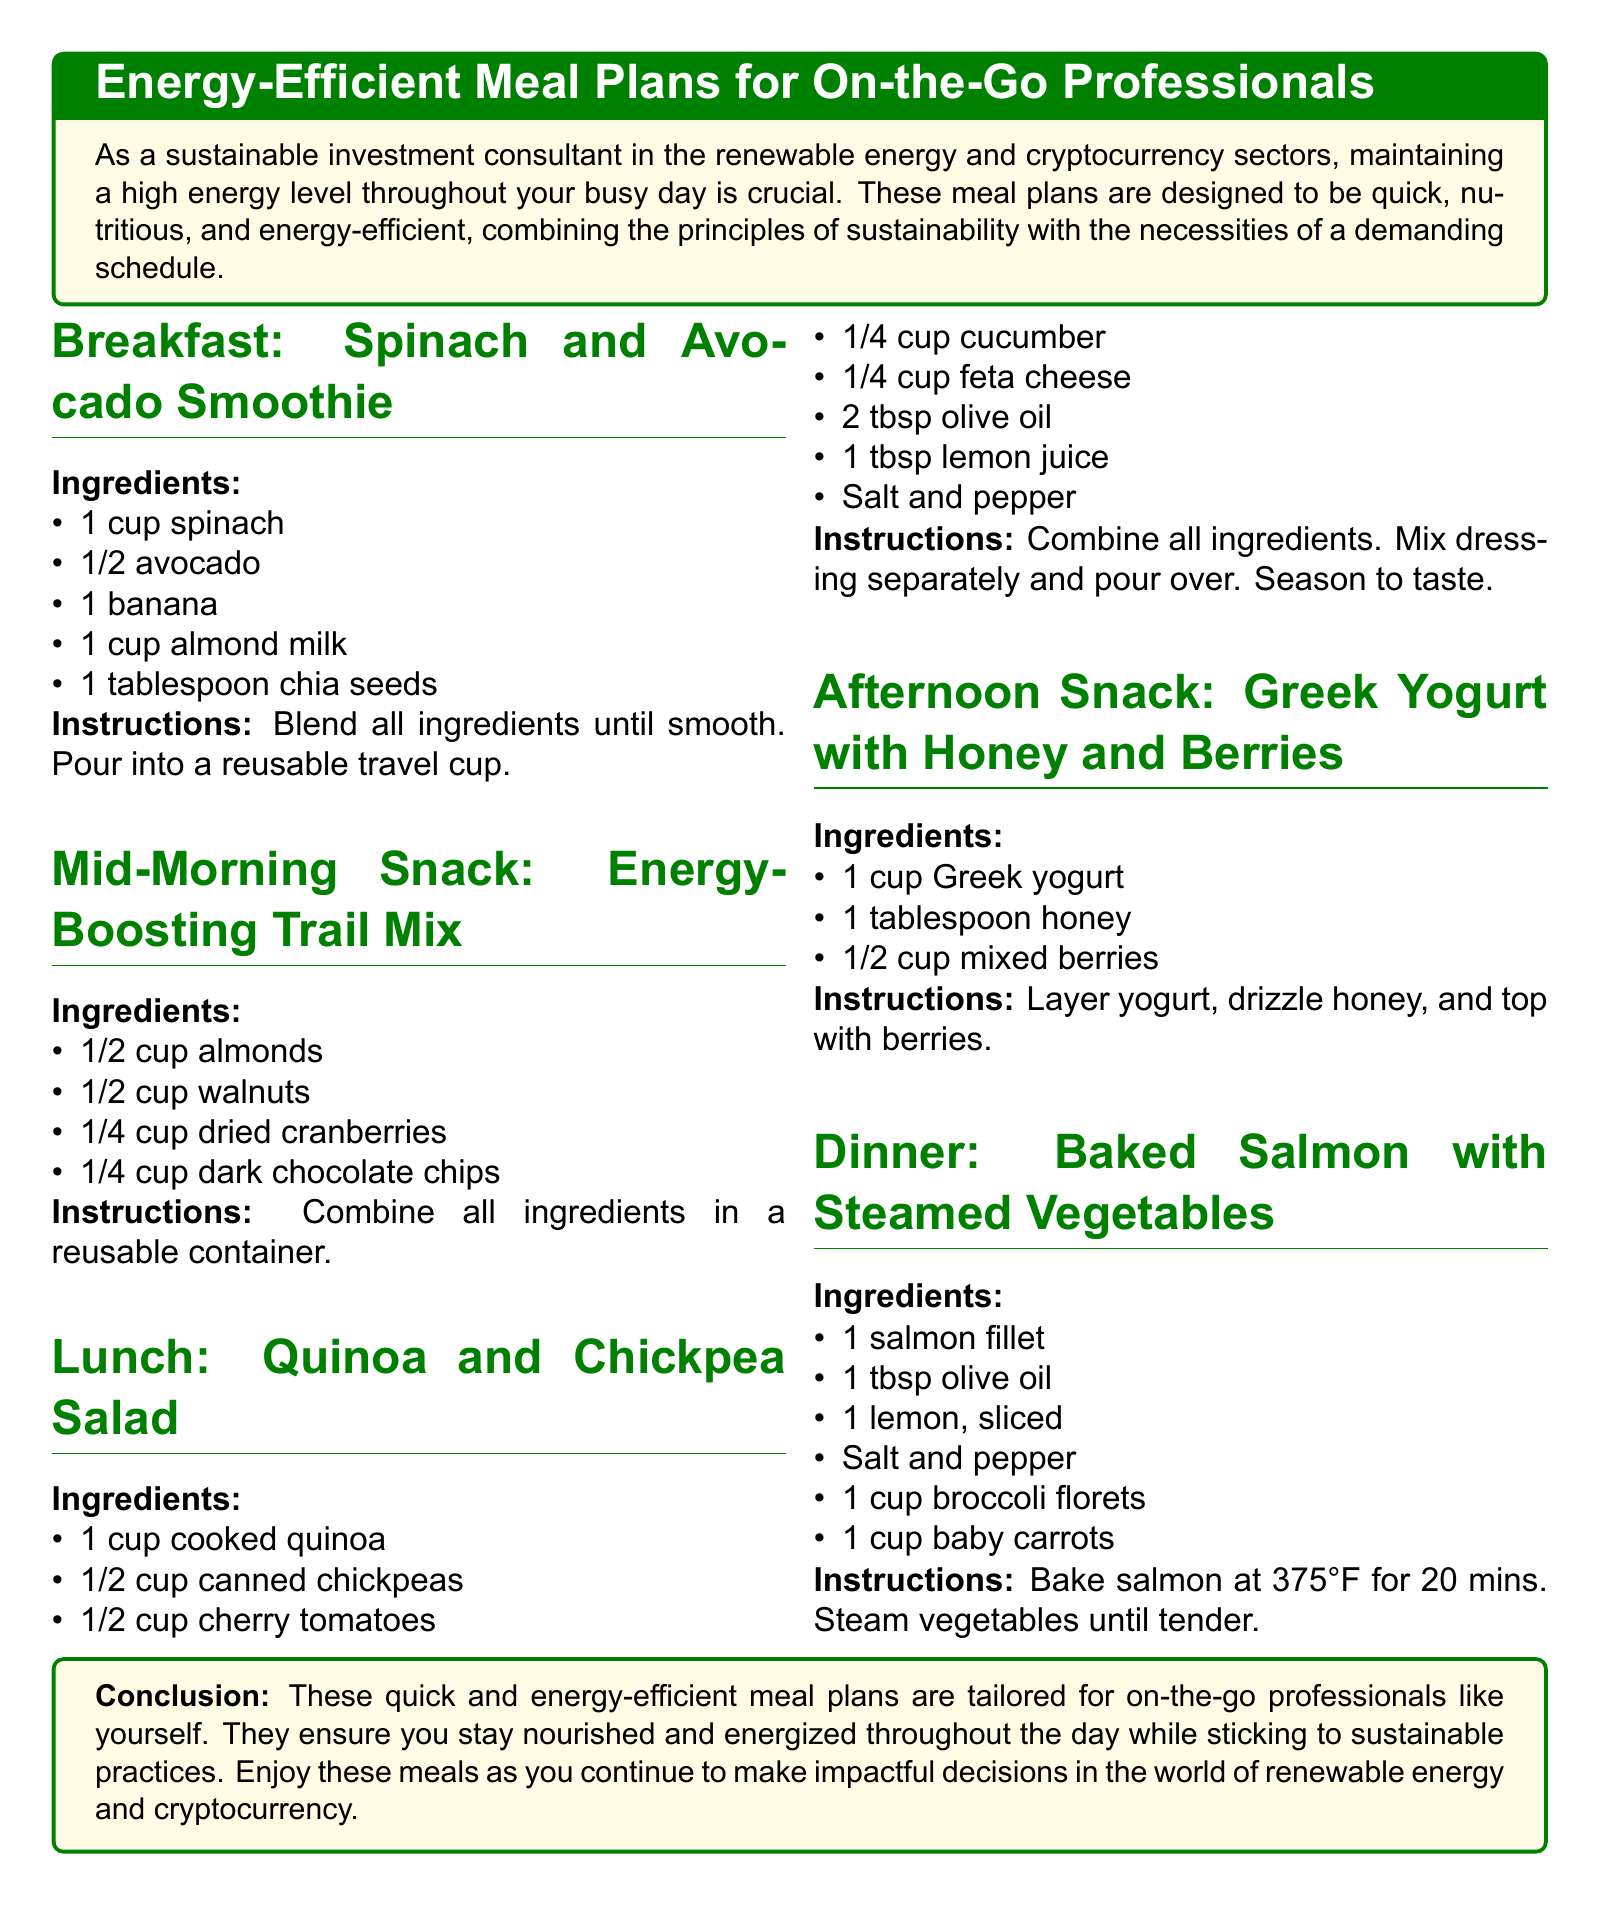What is the first meal listed? The first meal is identified in the document under Breakfast as "Spinach and Avocado Smoothie."
Answer: Spinach and Avocado Smoothie How many ingredients are in the lunch recipe? The lunch recipe for "Quinoa and Chickpea Salad" includes a total of eight ingredients.
Answer: 8 What is the primary protein source in the dinner meal? The primary protein source mentioned in the dinner section is "salmon fillet."
Answer: salmon fillet What type of container is recommended for the mid-morning snack? The mid-morning snack suggests using a "reusable container" for the trail mix.
Answer: reusable container How long should the salmon be baked? The document specifies that the salmon should be baked for "20 mins."
Answer: 20 mins What type of milk is used in the breakfast smoothie? The breakfast recipe calls for "almond milk."
Answer: almond milk What is one of the benefits of these meal plans? The benefits outlined include keeping professionals "nourished and energized."
Answer: nourished and energized What is the main color used for section titles? The main color utilized for the section titles is specified as "green."
Answer: green 